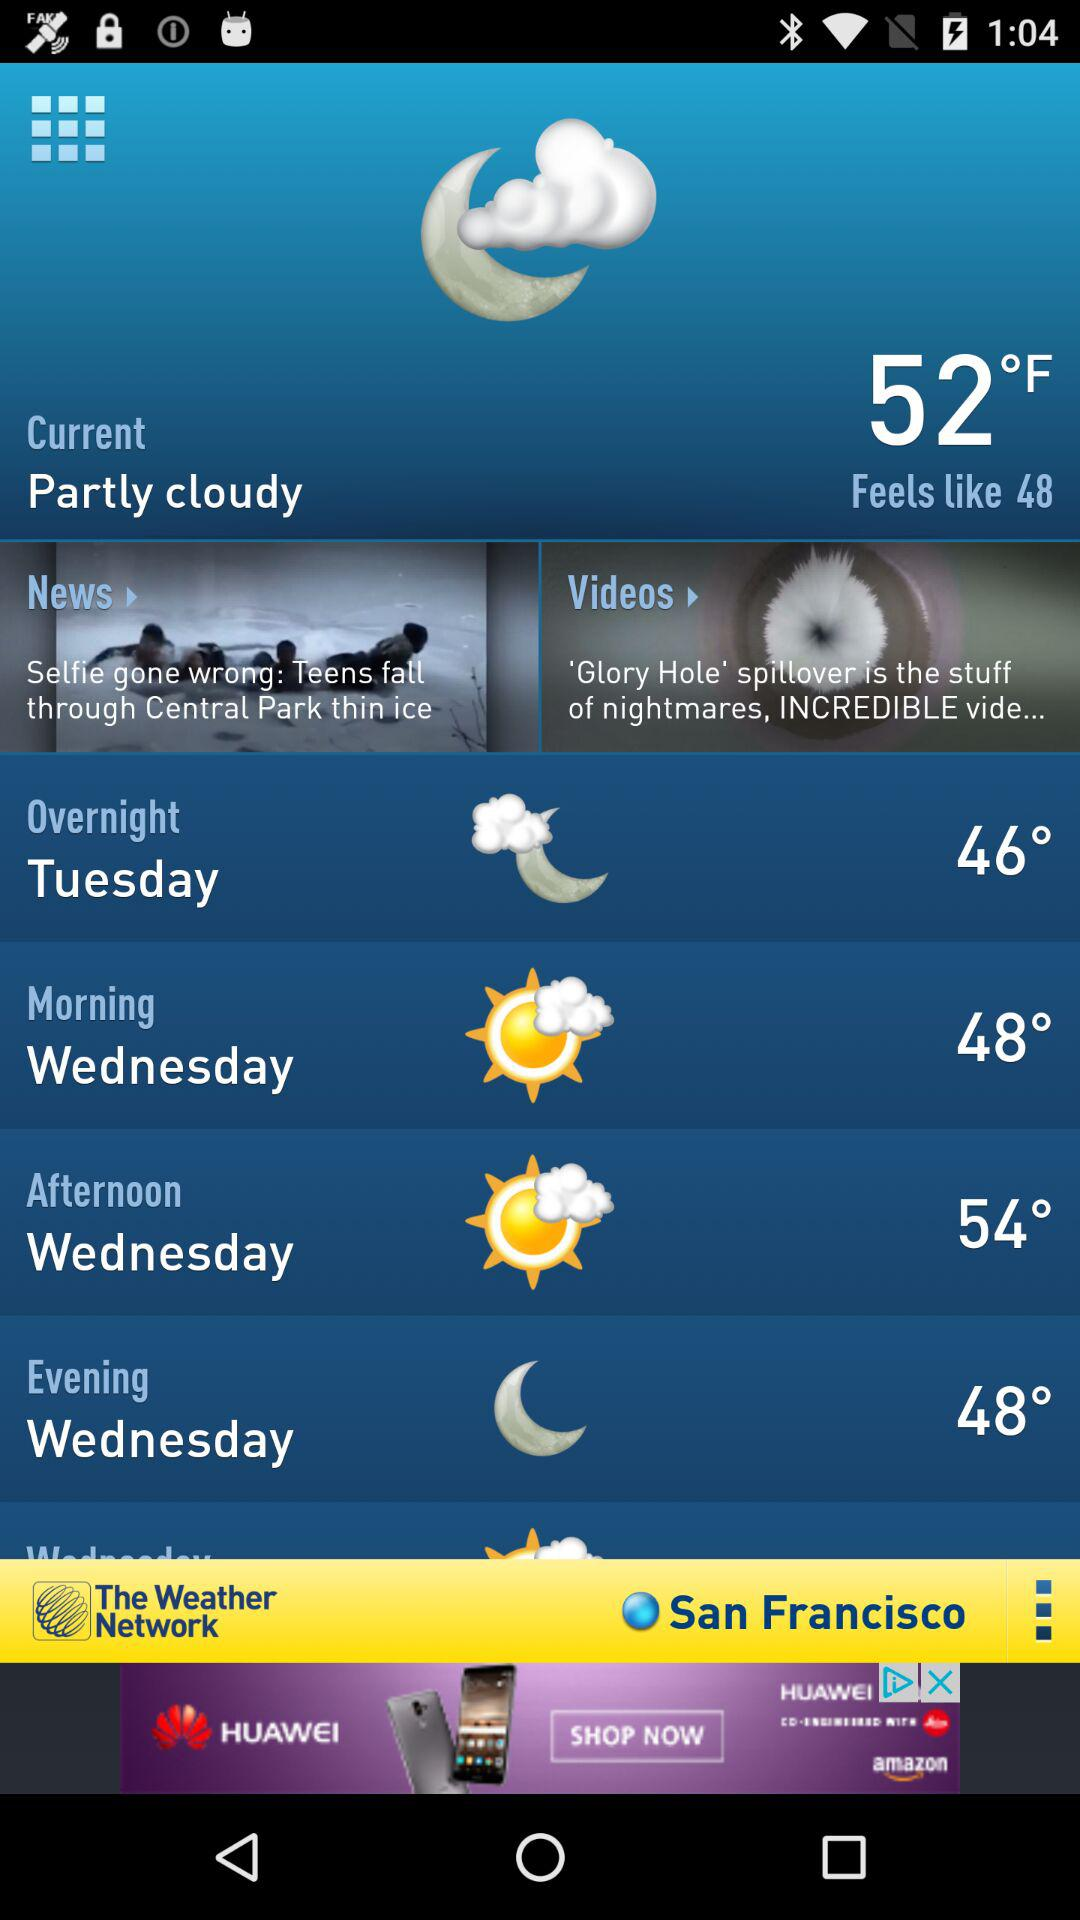What is the current location? The current location is San Francisco. 